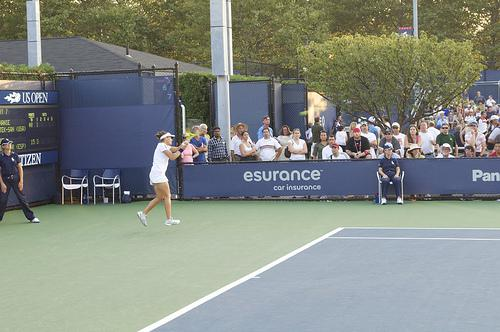Question: what sport is this?
Choices:
A. Badminton.
B. Hockey.
C. Soccer.
D. Tennis.
Answer with the letter. Answer: D Question: where is this scene?
Choices:
A. A basketball game.
B. A football game.
C. A soccer game.
D. On a tennis court.
Answer with the letter. Answer: D Question: what is she holding?
Choices:
A. Club.
B. Bat.
C. Racket.
D. Net.
Answer with the letter. Answer: C 